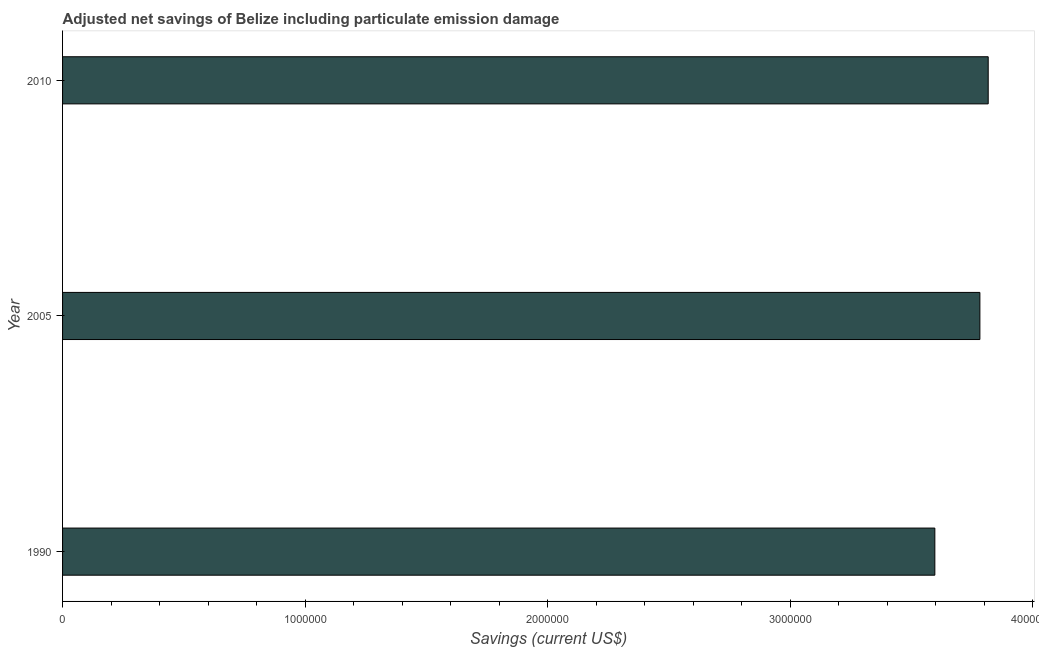Does the graph contain grids?
Provide a short and direct response. No. What is the title of the graph?
Your answer should be very brief. Adjusted net savings of Belize including particulate emission damage. What is the label or title of the X-axis?
Offer a very short reply. Savings (current US$). What is the adjusted net savings in 1990?
Give a very brief answer. 3.60e+06. Across all years, what is the maximum adjusted net savings?
Offer a very short reply. 3.82e+06. Across all years, what is the minimum adjusted net savings?
Ensure brevity in your answer.  3.60e+06. In which year was the adjusted net savings maximum?
Provide a succinct answer. 2010. In which year was the adjusted net savings minimum?
Offer a very short reply. 1990. What is the sum of the adjusted net savings?
Make the answer very short. 1.12e+07. What is the difference between the adjusted net savings in 1990 and 2005?
Give a very brief answer. -1.86e+05. What is the average adjusted net savings per year?
Offer a terse response. 3.73e+06. What is the median adjusted net savings?
Make the answer very short. 3.78e+06. In how many years, is the adjusted net savings greater than 3000000 US$?
Your answer should be very brief. 3. What is the ratio of the adjusted net savings in 1990 to that in 2010?
Offer a very short reply. 0.94. What is the difference between the highest and the second highest adjusted net savings?
Your answer should be compact. 3.43e+04. What is the difference between the highest and the lowest adjusted net savings?
Provide a succinct answer. 2.20e+05. In how many years, is the adjusted net savings greater than the average adjusted net savings taken over all years?
Your answer should be very brief. 2. Are all the bars in the graph horizontal?
Offer a terse response. Yes. How many years are there in the graph?
Your answer should be compact. 3. Are the values on the major ticks of X-axis written in scientific E-notation?
Your answer should be very brief. No. What is the Savings (current US$) of 1990?
Provide a short and direct response. 3.60e+06. What is the Savings (current US$) in 2005?
Offer a very short reply. 3.78e+06. What is the Savings (current US$) in 2010?
Keep it short and to the point. 3.82e+06. What is the difference between the Savings (current US$) in 1990 and 2005?
Your answer should be compact. -1.86e+05. What is the difference between the Savings (current US$) in 1990 and 2010?
Your answer should be very brief. -2.20e+05. What is the difference between the Savings (current US$) in 2005 and 2010?
Make the answer very short. -3.43e+04. What is the ratio of the Savings (current US$) in 1990 to that in 2005?
Offer a very short reply. 0.95. What is the ratio of the Savings (current US$) in 1990 to that in 2010?
Provide a succinct answer. 0.94. 